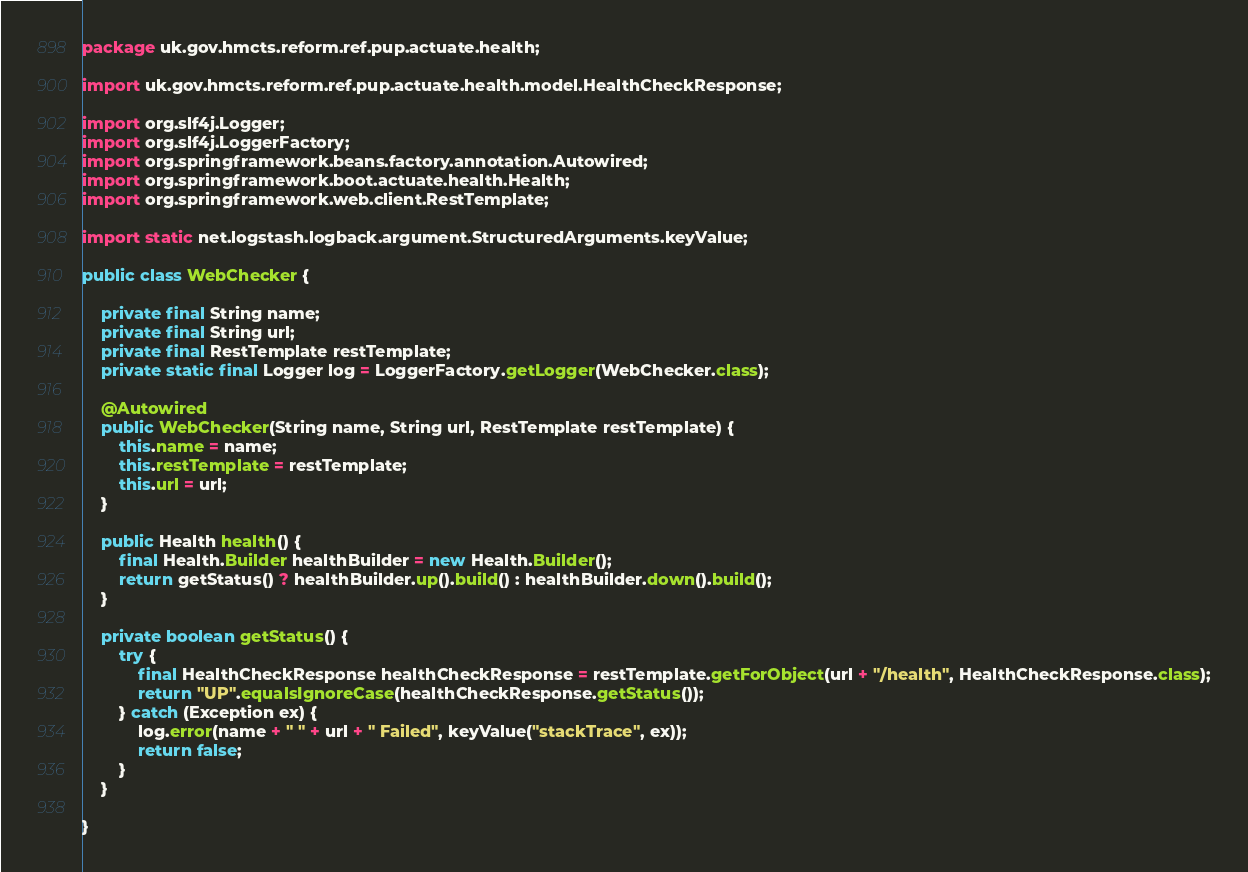Convert code to text. <code><loc_0><loc_0><loc_500><loc_500><_Java_>package uk.gov.hmcts.reform.ref.pup.actuate.health;

import uk.gov.hmcts.reform.ref.pup.actuate.health.model.HealthCheckResponse;

import org.slf4j.Logger;
import org.slf4j.LoggerFactory;
import org.springframework.beans.factory.annotation.Autowired;
import org.springframework.boot.actuate.health.Health;
import org.springframework.web.client.RestTemplate;

import static net.logstash.logback.argument.StructuredArguments.keyValue;

public class WebChecker {

    private final String name;
    private final String url;
    private final RestTemplate restTemplate;
    private static final Logger log = LoggerFactory.getLogger(WebChecker.class);

    @Autowired
    public WebChecker(String name, String url, RestTemplate restTemplate) {
        this.name = name;
        this.restTemplate = restTemplate;
        this.url = url;
    }

    public Health health() {
        final Health.Builder healthBuilder = new Health.Builder();
        return getStatus() ? healthBuilder.up().build() : healthBuilder.down().build();
    }

    private boolean getStatus() {
        try {
            final HealthCheckResponse healthCheckResponse = restTemplate.getForObject(url + "/health", HealthCheckResponse.class);
            return "UP".equalsIgnoreCase(healthCheckResponse.getStatus());
        } catch (Exception ex) {
            log.error(name + " " + url + " Failed", keyValue("stackTrace", ex));
            return false;
        }
    }

}
</code> 